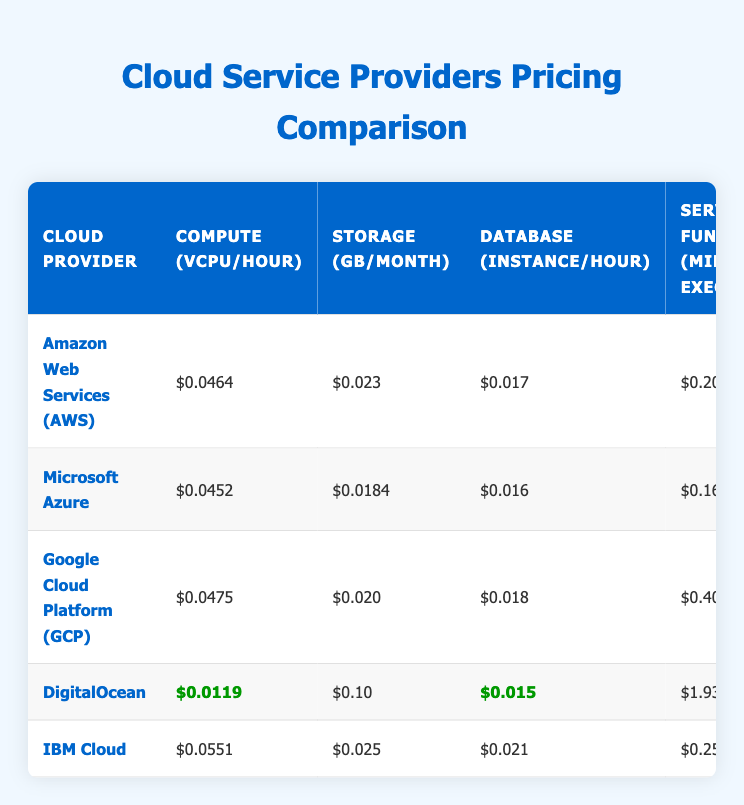What is the cost of Compute (vCPU/hour) for DigitalOcean? The table shows the pricing for each cloud provider. For DigitalOcean, the cost of Compute (vCPU/hour) is listed as $0.0119.
Answer: $0.0119 Which cloud provider has the most expensive Database (instance/hour)? To find the most expensive Database (instance/hour), we compare the values from each provider's listing. IBM Cloud has the highest cost at $0.021.
Answer: IBM Cloud What is the total monthly cost for using AWS services if a developer uses 100 CPU hours, 200 GB of storage, and 10 million serverless function executions? Calculate the costs individually first: Compute cost = 100 * $0.0464 = $4.64, Storage cost = 200 * $0.023 = $4.60, Serverless cost = 10 * $0.20 = $2.00. Then, sum them: $4.64 + $4.60 + $2.00 + $29 (Support Plan) = $40.24.
Answer: $40.24 Is it true that Google Cloud Platform has the lowest data transfer out cost? The table explicitly lists the Data Transfer Out costs for each provider. Google Cloud Platform's cost is $0.08, while DigitalOcean has the lowest cost at $0.01. Therefore, GCP does not have the lowest.
Answer: No What is the average cost of Storage (GB/month) among all providers? To calculate the average, first sum all the Storage costs: $0.023 + $0.0184 + $0.020 + $0.10 + $0.025 = $0.1864. There are 5 providers, so the average cost is $0.1864 / 5 = $0.03728.
Answer: $0.03728 Which cloud provider offers the cheapest rate for Serverless Functions (million executions)? Looking at the Serverless Functions costs in the table, DigitalOcean offers the cheapest rate at $1.93 million executions.
Answer: DigitalOcean How much more does IBM Cloud charge per hour for Load Balancer compared to DigitalOcean? The cost for Load Balancer on IBM Cloud is $0.03 and for DigitalOcean, it is $0.02. The difference is $0.03 - $0.02 = $0.01 more for IBM Cloud.
Answer: $0.01 Which provider has a support plan that costs more than $100? The only provider with a support plan costing more than $100 is IBM Cloud, which has a monthly cost of $200.
Answer: IBM Cloud 